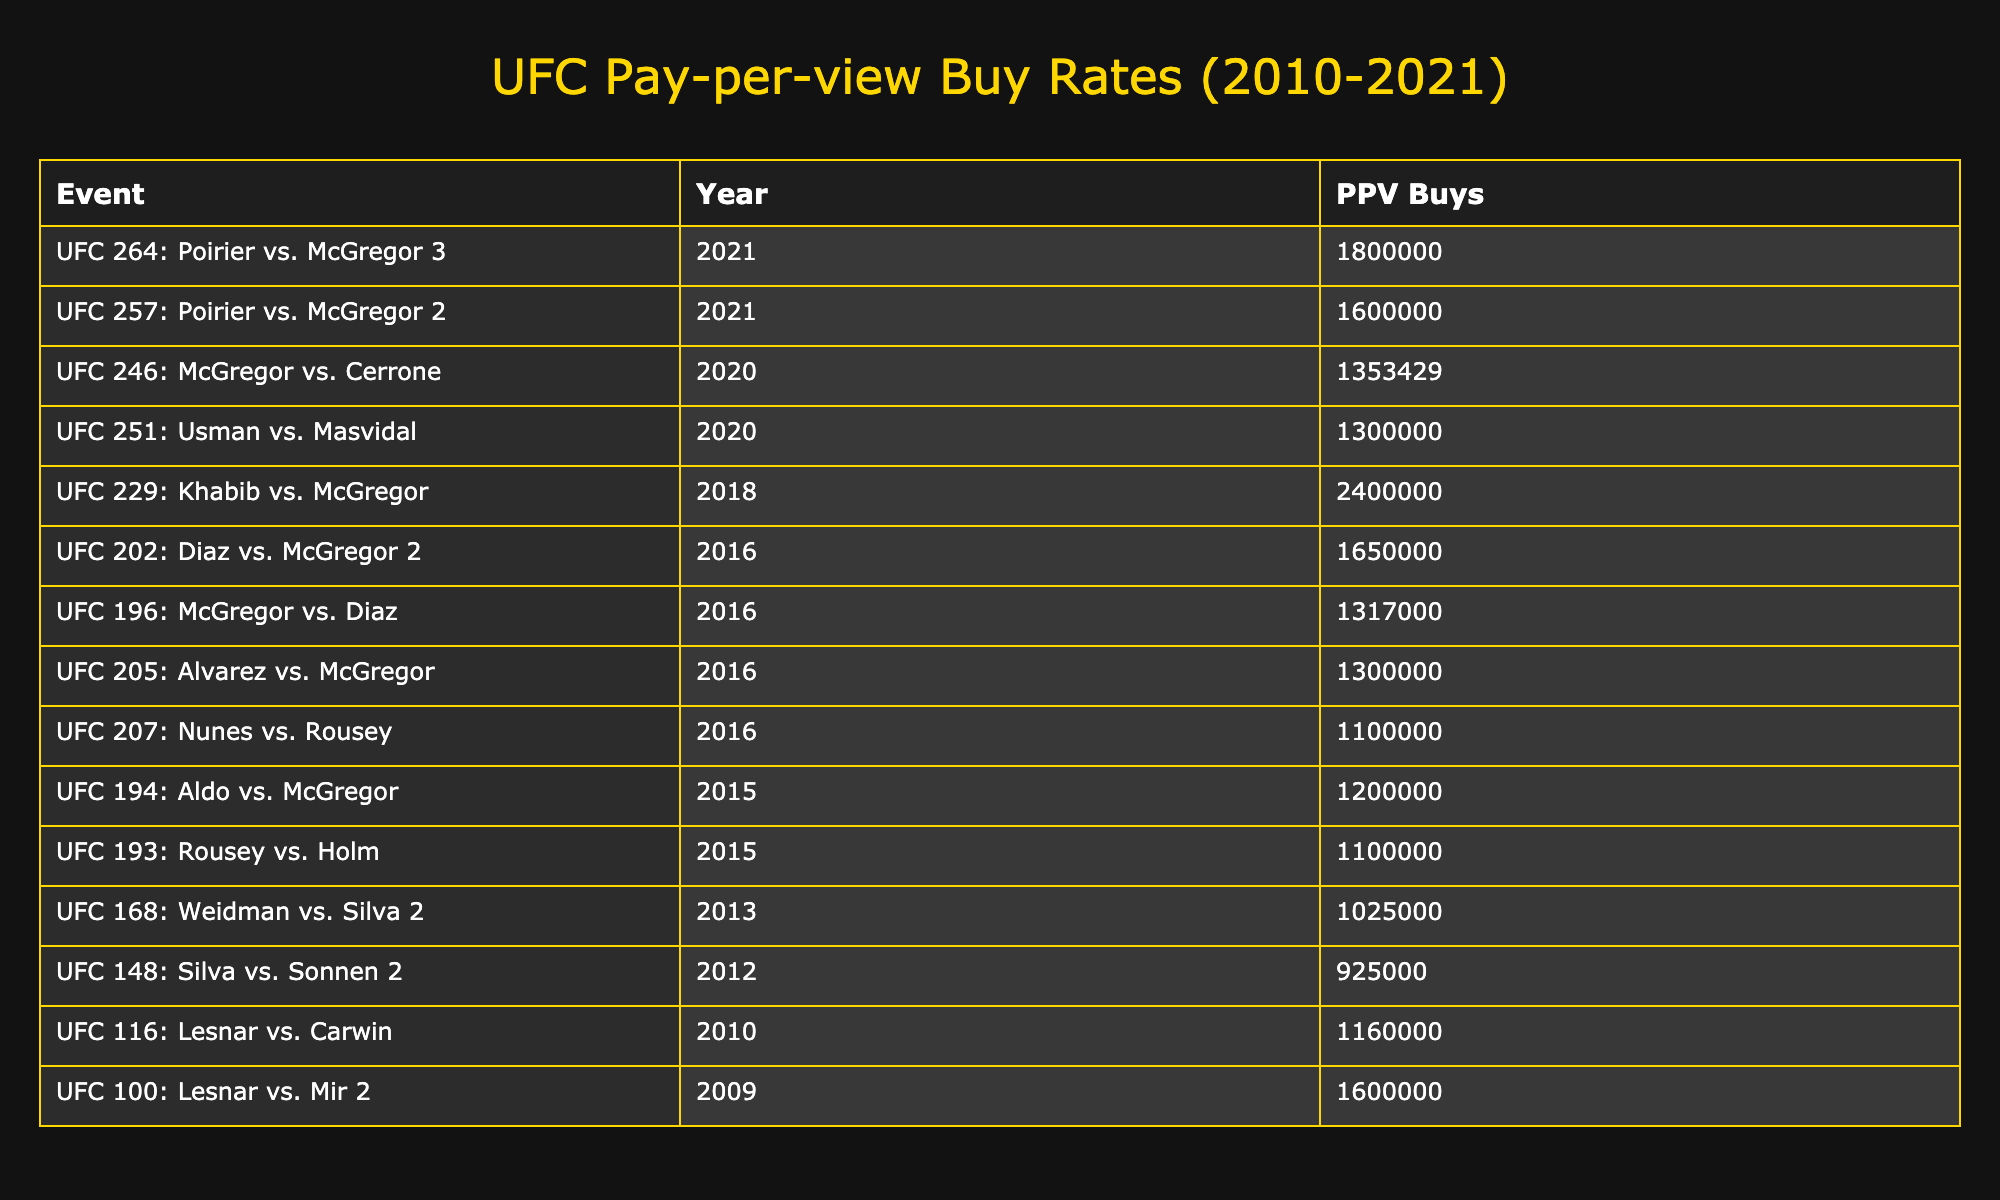What event had the highest PPV buys? To find the event with the highest PPV buys, I can look at the 'PPV Buys' column and identify the maximum value, which is 2,400,000 for UFC 229: Khabib vs. McGregor.
Answer: UFC 229: Khabib vs. McGregor What was the PPV buys for UFC 202: Diaz vs. McGregor 2? I can find UFC 202: Diaz vs. McGregor 2 in the table and check the corresponding value in the 'PPV Buys' column, which is 1,650,000.
Answer: 1,650,000 How many events had more than 1,000,000 PPV buys? I will count the number of entries in the 'PPV Buys' column that are greater than 1,000,000. The events with buys above 1,000,000 are UFC 116, UFC 202, UFC 229, UFC 100, UFC 194, UFC 196, UFC 205, UFC 257, UFC 246, UFC 264, and UFC 193, totaling 11 events.
Answer: 11 What is the average number of PPV buys for all the events listed? First, I need to sum all the PPV buys: (1,160,000 + 1,650,000 + 2,400,000 + 1,600,000 + 1,200,000 + 1,317,000 + 1,300,000 + 1,600,000 + 1,353,429 + 1,800,000 + 1,100,000 + 1,100,000 + 1,300,000 + 1,025,000 + 925,000) = 16,615,429. There are 15 events, so the average is 16,615,429 / 15 = 1,107,695.
Answer: 1,107,695 Which year had the highest total PPV buys when combining all events? I will aggregate the PPV buys by year: 2010 (1,160,000), 2011 (0), 2012 (925,000), 2013 (1,025,000), 2014 (0), 2015 (2,300,000), 2016 (5,057,000), 2017 (0), 2018 (2,400,000), 2019 (0), 2020 (2,635,429), and 2021 (3,800,000). The highest is 5,057,000 in 2016.
Answer: 2016 Did all UFC events since 2010 surpass 900,000 PPV buys? By reviewing the PPV buys in the table, I can see that not all events surpassed 900,000; for example, UFC 148 had 925,000, which is just at the threshold.
Answer: No Which two events had the lowest PPV buys since 2010? To find the lowest PPV buys, I will look for the two smallest values in the table: 925,000 for UFC 148 and 1,025,000 for UFC 168.
Answer: UFC 148: Silva vs. Sonnen 2 and UFC 168: Weidman vs. Silva 2 What percentage of total PPV buys does UFC 229 contribute? I will first find the total PPV buys (16,615,429 from earlier) and then calculate 2,400,000 (UFC 229 buys) in percentage form: (2,400,000 / 16,615,429) * 100 = approximately 14.45%.
Answer: 14.45% 